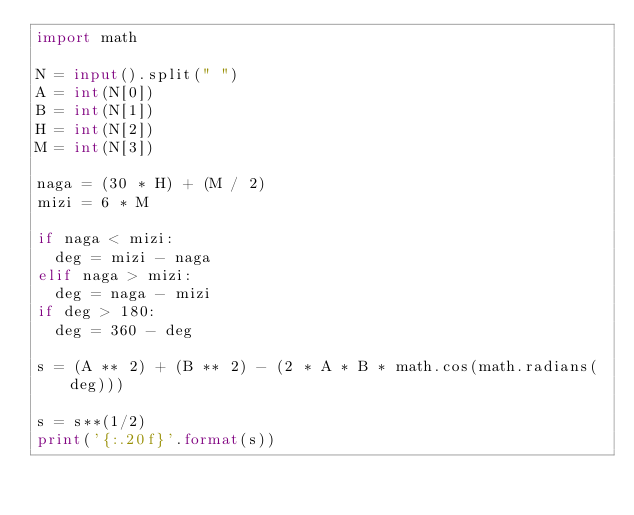Convert code to text. <code><loc_0><loc_0><loc_500><loc_500><_Python_>import math

N = input().split(" ")
A = int(N[0])
B = int(N[1])
H = int(N[2])
M = int(N[3])

naga = (30 * H) + (M / 2)
mizi = 6 * M

if naga < mizi:
  deg = mizi - naga
elif naga > mizi:
  deg = naga - mizi
if deg > 180:
  deg = 360 - deg

s = (A ** 2) + (B ** 2) - (2 * A * B * math.cos(math.radians(deg)))

s = s**(1/2)
print('{:.20f}'.format(s))</code> 